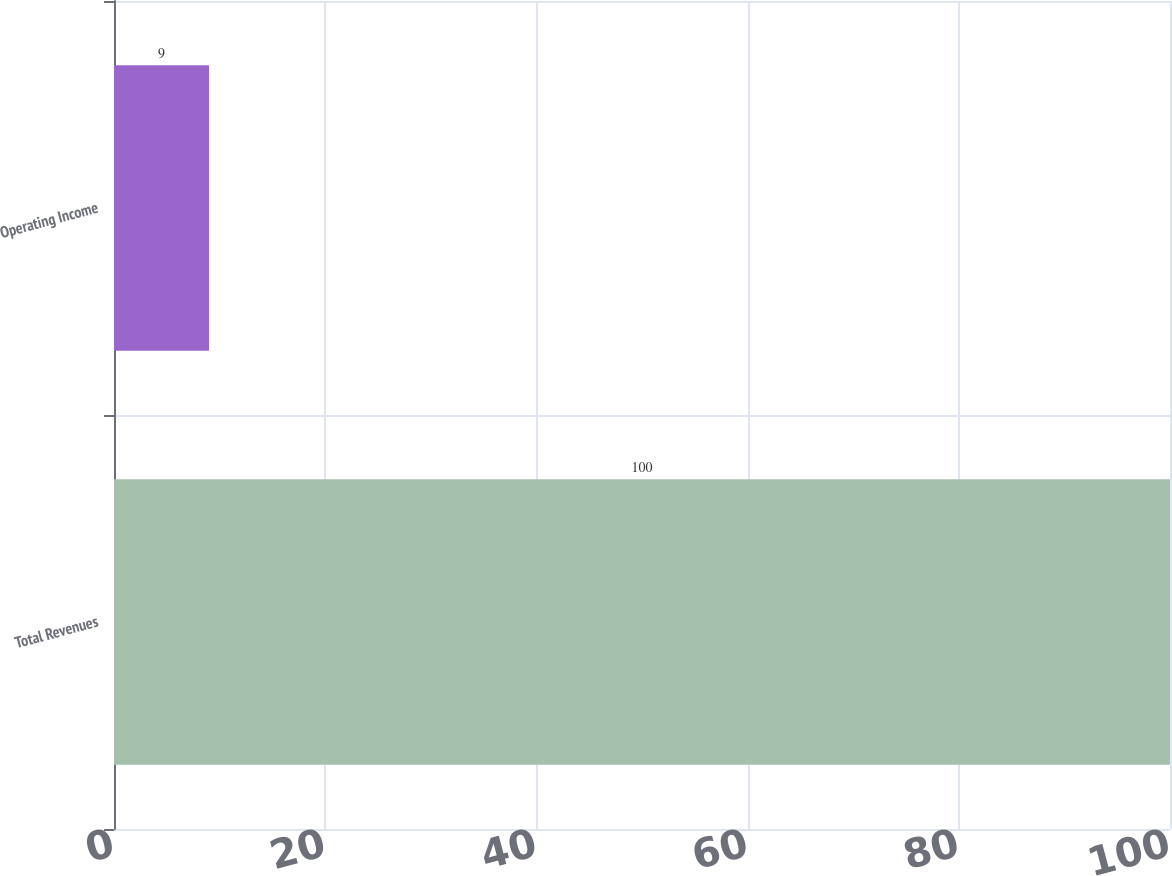Convert chart. <chart><loc_0><loc_0><loc_500><loc_500><bar_chart><fcel>Total Revenues<fcel>Operating Income<nl><fcel>100<fcel>9<nl></chart> 